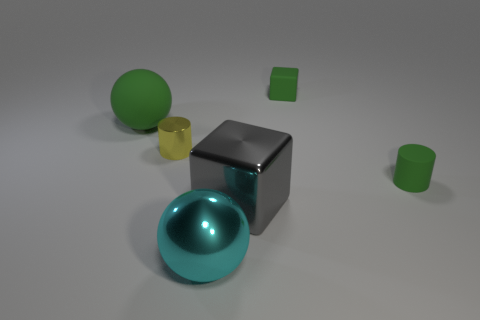Can you tell me about the lighting in this scene? The lighting in the scene is soft and diffused, casting gentle shadows that suggest an ambient light source, possibly from above. 